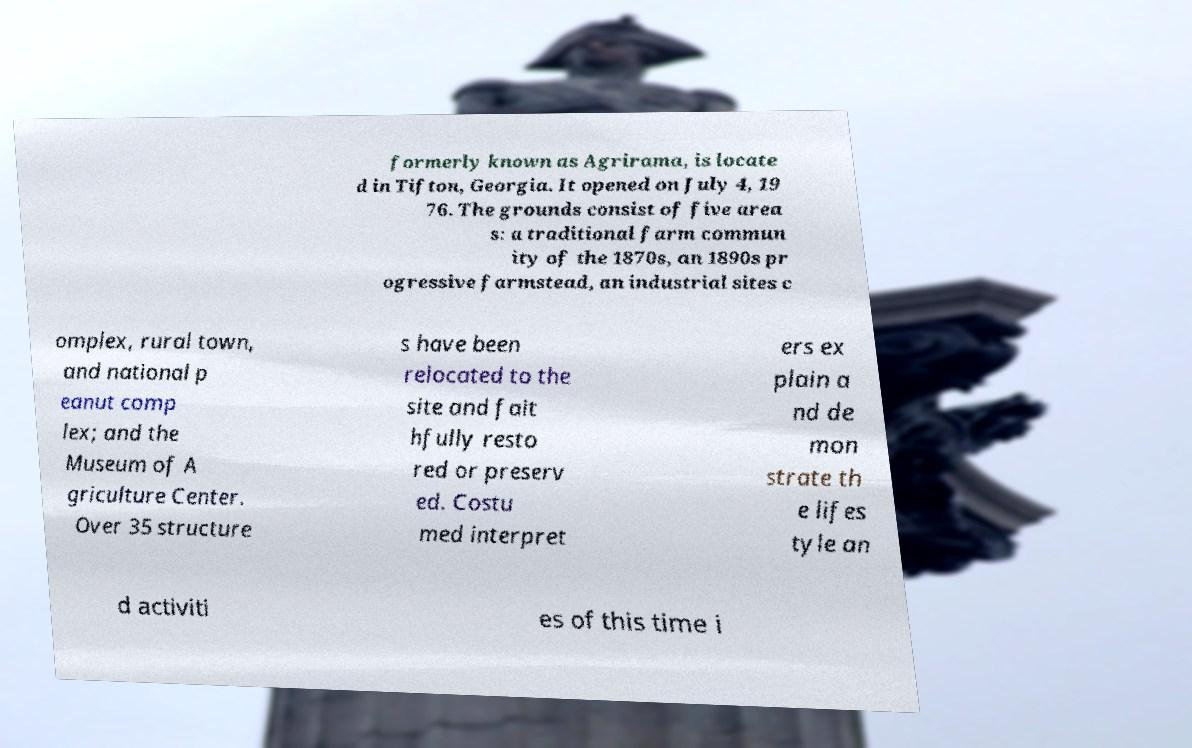I need the written content from this picture converted into text. Can you do that? formerly known as Agrirama, is locate d in Tifton, Georgia. It opened on July 4, 19 76. The grounds consist of five area s: a traditional farm commun ity of the 1870s, an 1890s pr ogressive farmstead, an industrial sites c omplex, rural town, and national p eanut comp lex; and the Museum of A griculture Center. Over 35 structure s have been relocated to the site and fait hfully resto red or preserv ed. Costu med interpret ers ex plain a nd de mon strate th e lifes tyle an d activiti es of this time i 